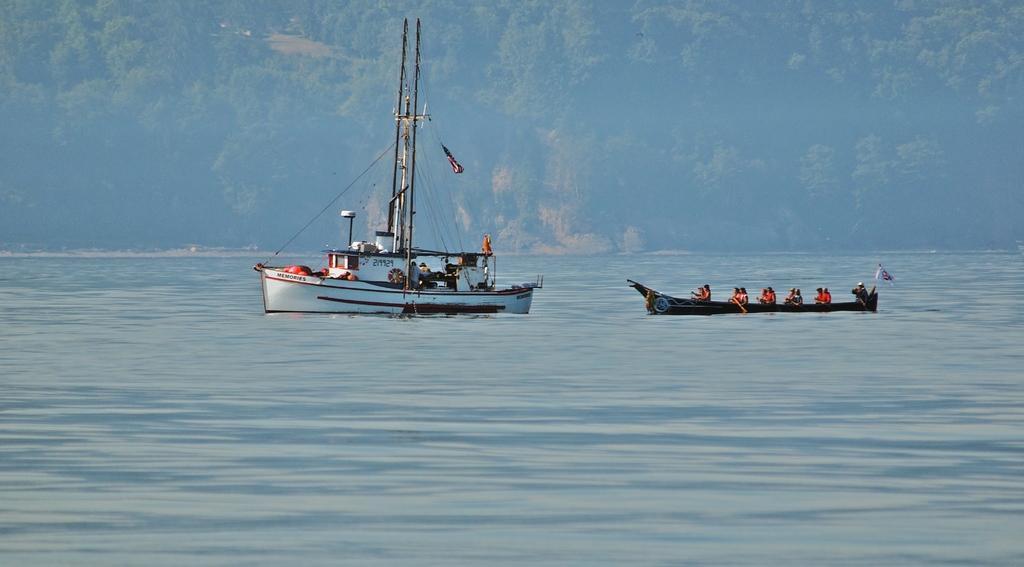Describe this image in one or two sentences. In the picture we can see trireme which is sailing on water, there are some people sitting in a boat and rowing and in the background of the picture there are some trees, mountain. 